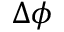<formula> <loc_0><loc_0><loc_500><loc_500>\Delta \phi</formula> 